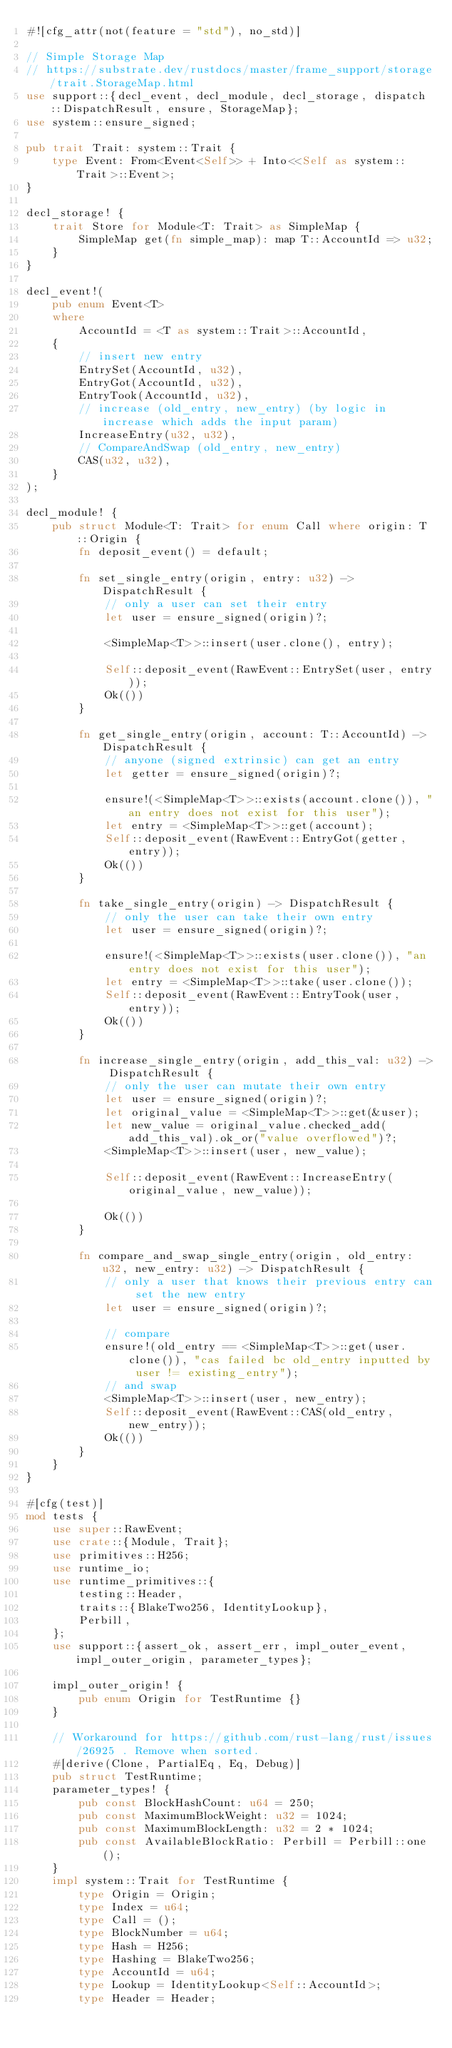Convert code to text. <code><loc_0><loc_0><loc_500><loc_500><_Rust_>#![cfg_attr(not(feature = "std"), no_std)]

// Simple Storage Map
// https://substrate.dev/rustdocs/master/frame_support/storage/trait.StorageMap.html
use support::{decl_event, decl_module, decl_storage, dispatch::DispatchResult, ensure, StorageMap};
use system::ensure_signed;

pub trait Trait: system::Trait {
    type Event: From<Event<Self>> + Into<<Self as system::Trait>::Event>;
}

decl_storage! {
    trait Store for Module<T: Trait> as SimpleMap {
        SimpleMap get(fn simple_map): map T::AccountId => u32;
    }
}

decl_event!(
    pub enum Event<T>
    where
        AccountId = <T as system::Trait>::AccountId,
    {
        // insert new entry
        EntrySet(AccountId, u32),
        EntryGot(AccountId, u32),
        EntryTook(AccountId, u32),
        // increase (old_entry, new_entry) (by logic in increase which adds the input param)
        IncreaseEntry(u32, u32),
        // CompareAndSwap (old_entry, new_entry)
        CAS(u32, u32),
    }
);

decl_module! {
    pub struct Module<T: Trait> for enum Call where origin: T::Origin {
        fn deposit_event() = default;

        fn set_single_entry(origin, entry: u32) -> DispatchResult {
            // only a user can set their entry
            let user = ensure_signed(origin)?;

            <SimpleMap<T>>::insert(user.clone(), entry);

            Self::deposit_event(RawEvent::EntrySet(user, entry));
            Ok(())
        }

        fn get_single_entry(origin, account: T::AccountId) -> DispatchResult {
            // anyone (signed extrinsic) can get an entry
            let getter = ensure_signed(origin)?;

            ensure!(<SimpleMap<T>>::exists(account.clone()), "an entry does not exist for this user");
            let entry = <SimpleMap<T>>::get(account);
            Self::deposit_event(RawEvent::EntryGot(getter, entry));
            Ok(())
        }

        fn take_single_entry(origin) -> DispatchResult {
            // only the user can take their own entry
            let user = ensure_signed(origin)?;

            ensure!(<SimpleMap<T>>::exists(user.clone()), "an entry does not exist for this user");
            let entry = <SimpleMap<T>>::take(user.clone());
            Self::deposit_event(RawEvent::EntryTook(user, entry));
            Ok(())
        }

        fn increase_single_entry(origin, add_this_val: u32) -> DispatchResult {
            // only the user can mutate their own entry
            let user = ensure_signed(origin)?;
            let original_value = <SimpleMap<T>>::get(&user);
            let new_value = original_value.checked_add(add_this_val).ok_or("value overflowed")?;
            <SimpleMap<T>>::insert(user, new_value);

            Self::deposit_event(RawEvent::IncreaseEntry(original_value, new_value));

            Ok(())
        }

        fn compare_and_swap_single_entry(origin, old_entry: u32, new_entry: u32) -> DispatchResult {
            // only a user that knows their previous entry can set the new entry
            let user = ensure_signed(origin)?;

            // compare
            ensure!(old_entry == <SimpleMap<T>>::get(user.clone()), "cas failed bc old_entry inputted by user != existing_entry");
            // and swap
            <SimpleMap<T>>::insert(user, new_entry);
            Self::deposit_event(RawEvent::CAS(old_entry, new_entry));
            Ok(())
        }
    }
}

#[cfg(test)]
mod tests {
    use super::RawEvent;
    use crate::{Module, Trait};
    use primitives::H256;
    use runtime_io;
    use runtime_primitives::{
        testing::Header,
        traits::{BlakeTwo256, IdentityLookup},
        Perbill,
    };
    use support::{assert_ok, assert_err, impl_outer_event, impl_outer_origin, parameter_types};

    impl_outer_origin! {
        pub enum Origin for TestRuntime {}
    }

    // Workaround for https://github.com/rust-lang/rust/issues/26925 . Remove when sorted.
    #[derive(Clone, PartialEq, Eq, Debug)]
    pub struct TestRuntime;
    parameter_types! {
        pub const BlockHashCount: u64 = 250;
        pub const MaximumBlockWeight: u32 = 1024;
        pub const MaximumBlockLength: u32 = 2 * 1024;
        pub const AvailableBlockRatio: Perbill = Perbill::one();
    }
    impl system::Trait for TestRuntime {
        type Origin = Origin;
        type Index = u64;
        type Call = ();
        type BlockNumber = u64;
        type Hash = H256;
        type Hashing = BlakeTwo256;
        type AccountId = u64;
        type Lookup = IdentityLookup<Self::AccountId>;
        type Header = Header;</code> 